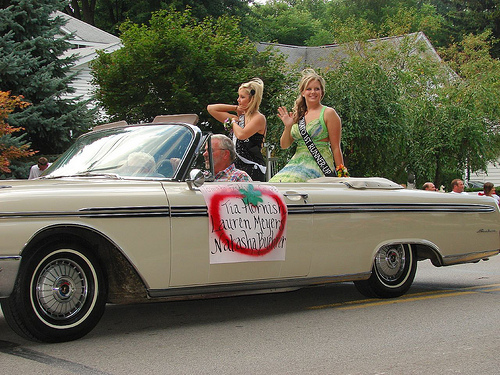<image>
Is the women next to the men? Yes. The women is positioned adjacent to the men, located nearby in the same general area. 